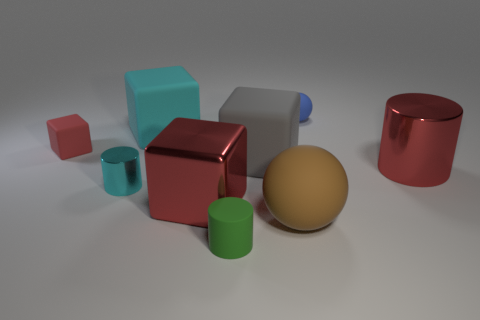Subtract all metallic cylinders. How many cylinders are left? 1 Subtract all brown balls. How many red cubes are left? 2 Subtract 1 cylinders. How many cylinders are left? 2 Subtract all gray cubes. How many cubes are left? 3 Add 1 metallic objects. How many objects exist? 10 Subtract all yellow cylinders. Subtract all green spheres. How many cylinders are left? 3 Subtract all spheres. How many objects are left? 7 Add 8 big gray matte objects. How many big gray matte objects are left? 9 Add 4 cyan cylinders. How many cyan cylinders exist? 5 Subtract 0 gray cylinders. How many objects are left? 9 